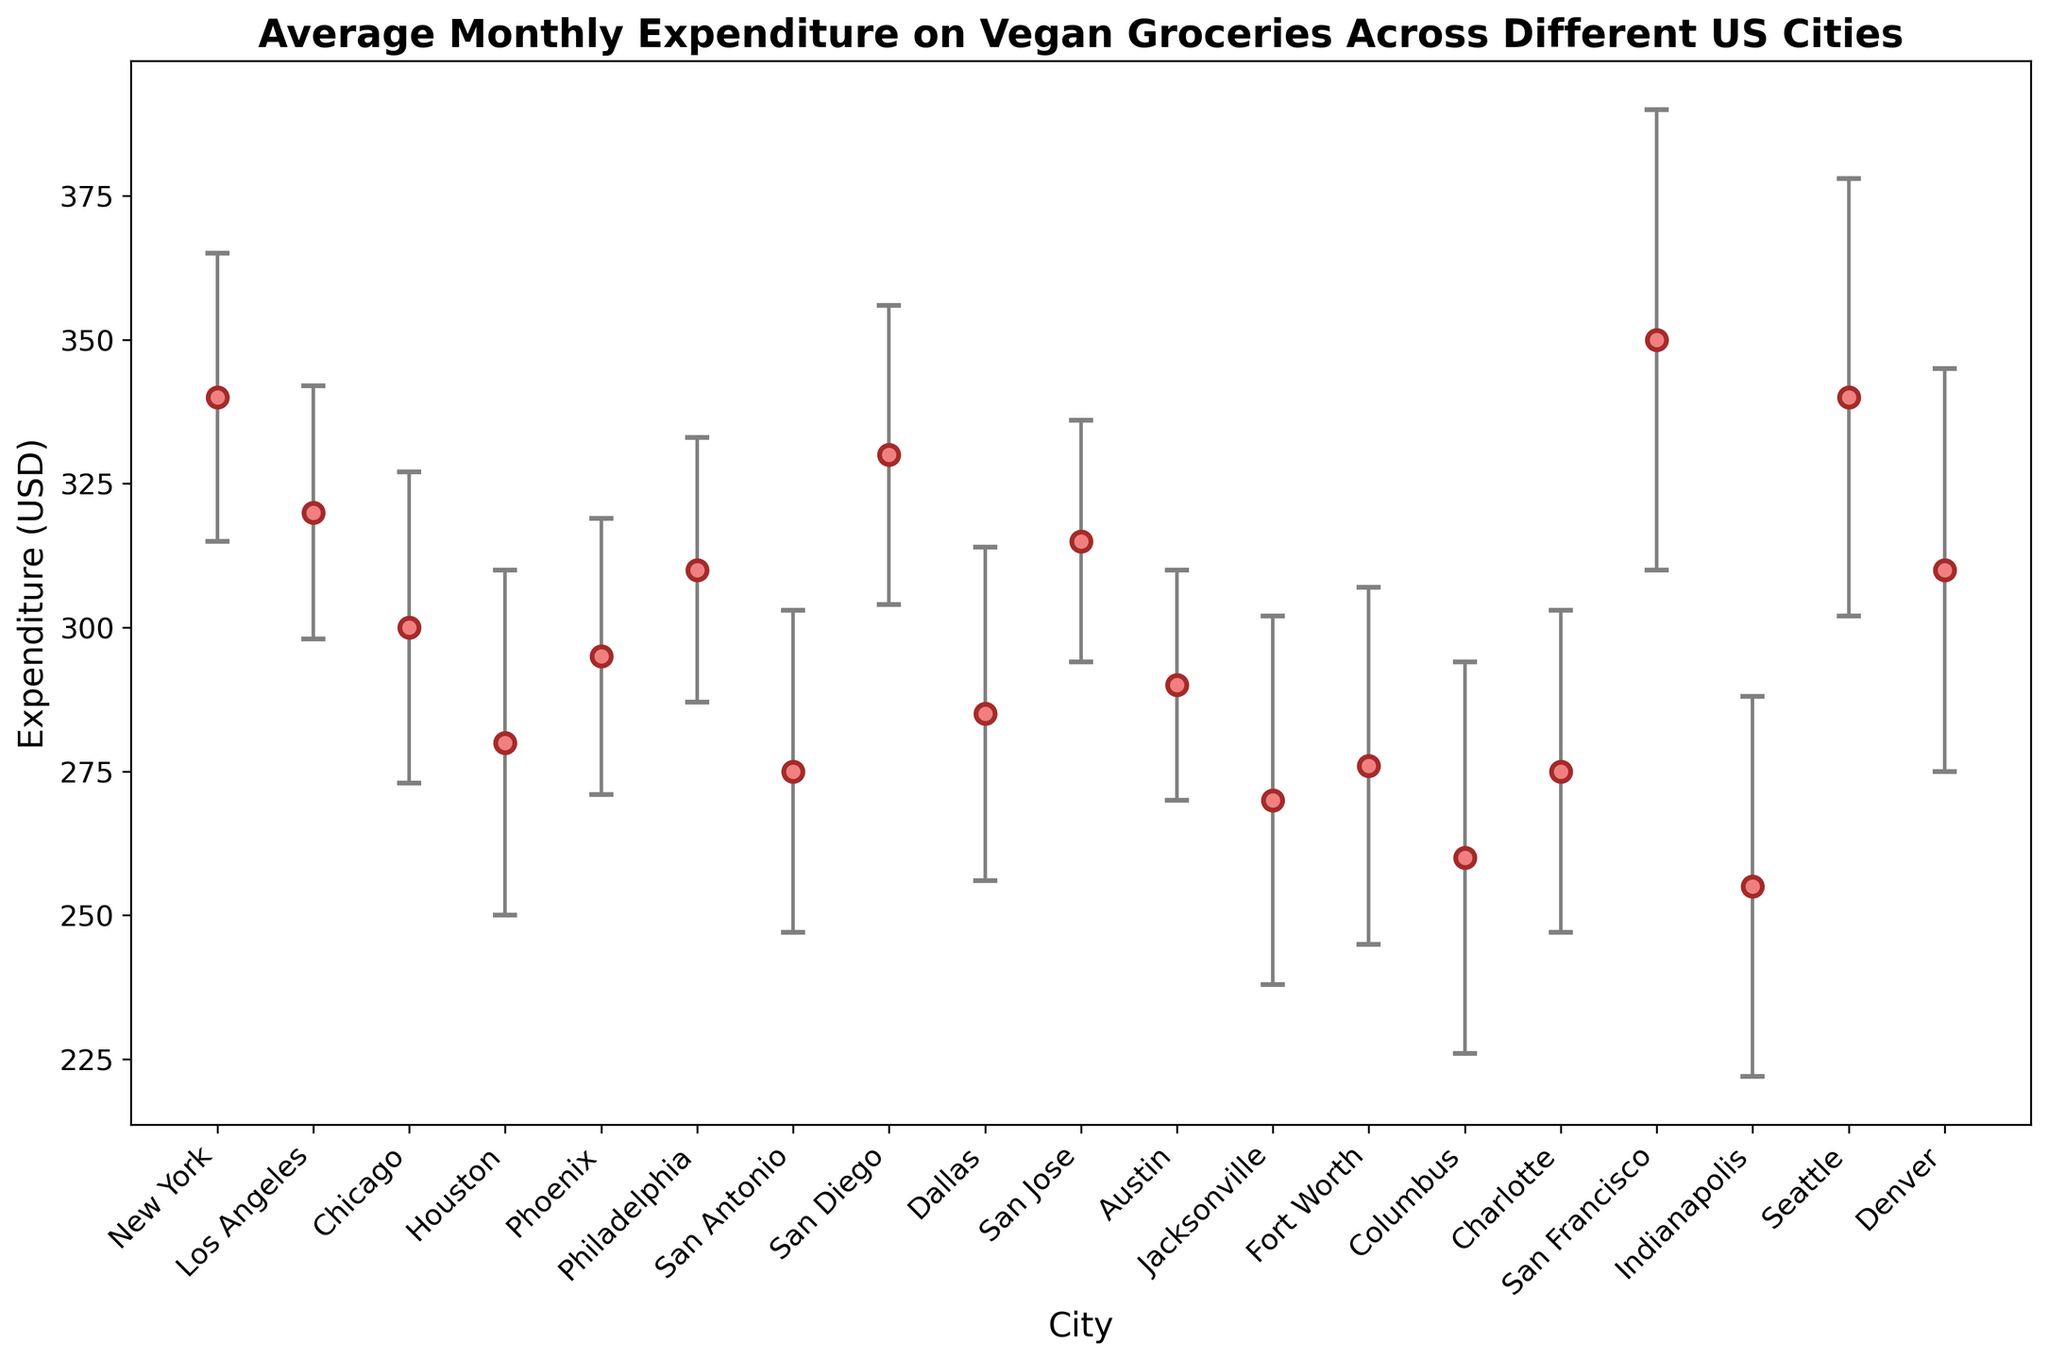what is the average monthly expenditure in New York City compared to San Francisco? To find the comparison, look at the data points for New York (340 USD) and San Francisco (350 USD). The comparison shows which is higher or lower.
Answer: San Francisco has a higher average expenditure Which city has the lowest average monthly expenditure on vegan groceries? By visually scanning the error bar chart, identify the city with the lowest expenditure along the y-axis. Indianapolis has the lowest value, which is 255 USD.
Answer: Indianapolis What is the difference in average monthly expenditure between Chicago and Houston? Identify the average monthly expenditures which are 300 USD for Chicago and 280 USD for Houston. The difference is calculated by subtracting 280 from 300.
Answer: 20 USD Which city has the highest standard deviation in expenditure? Review the error bars to determine which city has the widest (tallest) error bar, indicating the highest standard deviation. San Francisco has the largest standard deviation, 40 USD.
Answer: San Francisco Compare the average monthly expenditures between cities in California (Los Angeles, San Diego, San Jose, San Francisco) and Texas (Houston, San Antonio, Dallas, Austin). Which state has a higher average expenditure? Calculate the average for each state's cities. For California: (320+330+315+350)/4 = 328.75 USD. For Texas: (280+275+285+290)/4 = 282.5 USD. California has a higher average expenditure.
Answer: California Which city’s expenditure is closest to the average expenditure across all cities? First, calculate the overall average: (340+320+300+280+295+310+275+330+285+315+290+270+276+260+275+350+255+340+310)/19 = 302.11 USD. Then, find the city nearest to this value, which is Philadelphia with 310 USD.
Answer: Philadelphia Identify the city with expenditure closest to its average within one standard deviation. Look for the city where the value and standard deviation make it closest to the center of its range. Los Angeles has 320 USD and a standard deviation of 22, keeping its range between 298-342 USD, and expenditure is close to its average.
Answer: Los Angeles Which city has an expenditure that is outside two standard deviations when comparing to an average of 302.11 USD? Calculate two standard deviations range = 302.11 ± 2*34. Find cities outside 234.11 USD to 370.11 USD. San Francisco with 350 USD and others within the range.
Answer: None is outside two deviations If standard deviations were halved, which city would have the smallest range of monthly expenditure? Halve the values (e.g., San Francisco: 40/2=20). The city with the smallest halved SD is Austin, originally 20, now 10.
Answer: Austin 